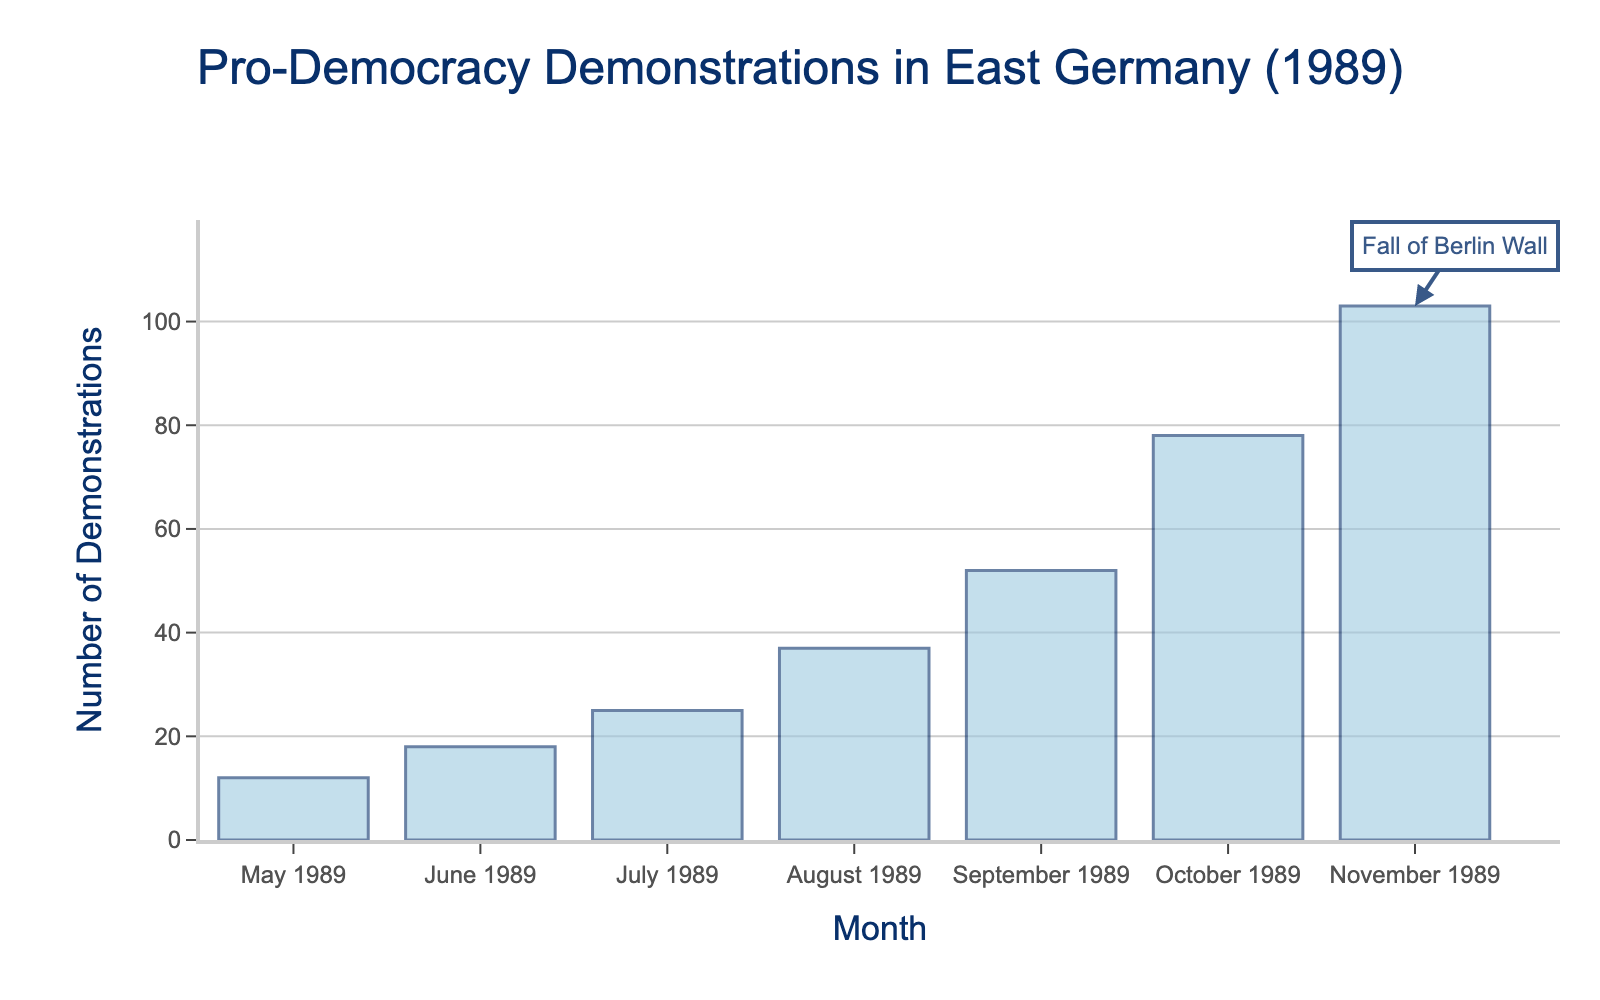What is the title of the histogram? The title of the histogram is located at the top and reads "Pro-Democracy Demonstrations in East Germany (1989)".
Answer: Pro-Democracy Demonstrations in East Germany (1989) What is the highest number of pro-democracy demonstrations in a single month? The bar for November 1989 is the tallest, and it indicates 103 demonstrations.
Answer: 103 What is the axis title for the vertical axis? The vertical axis title is labeled "Number of Demonstrations".
Answer: Number of Demonstrations In which month did East Germany witness the fewest number of pro-democracy demonstrations? May 1989 has the shortest bar representing the fewest demonstrations, with a value of 12.
Answer: May 1989 How did the number of demonstrations change from June 1989 to July 1989? Comparing the bar heights of June and July, the number increased from 18 to 25. This is an increase of 7 demonstrations.
Answer: Increased by 7 Which month experienced the largest increase in the number of pro-democracy demonstrations compared to the previous month? By calculating the month-over-month increase, the largest increase occurs from October 1989 to November 1989, which is 103 - 78 = 25 demonstrations.
Answer: October to November 1989 What is the sum of the number of pro-democracy demonstrations from May 1989 to July 1989? Adding the values for May (12), June (18), and July (25), the sum is 12 + 18 + 25 = 55 demonstrations.
Answer: 55 In which month is the "Fall of Berlin Wall" annotation located? The annotation "Fall of Berlin Wall" is placed in November 1989, as indicated by the arrow pointing at the highest bar.
Answer: November 1989 Compare the number of demonstrations in August 1989 and September 1989. Which month had more demonstrations and by how much? August 1989 had 37 demonstrations, and September 1989 had 52. Subtracting these, September had 52 - 37 = 15 more demonstrations than August.
Answer: September by 15 What is the average number of pro-democracy demonstrations from August 1989 to November 1989? Adding the demonstrations from August (37), September (52), October (78), and November (103), the total is 37 + 52 + 78 + 103 = 270. There are 4 months, so the average is 270 / 4 = 67.5 demonstrations.
Answer: 67.5 